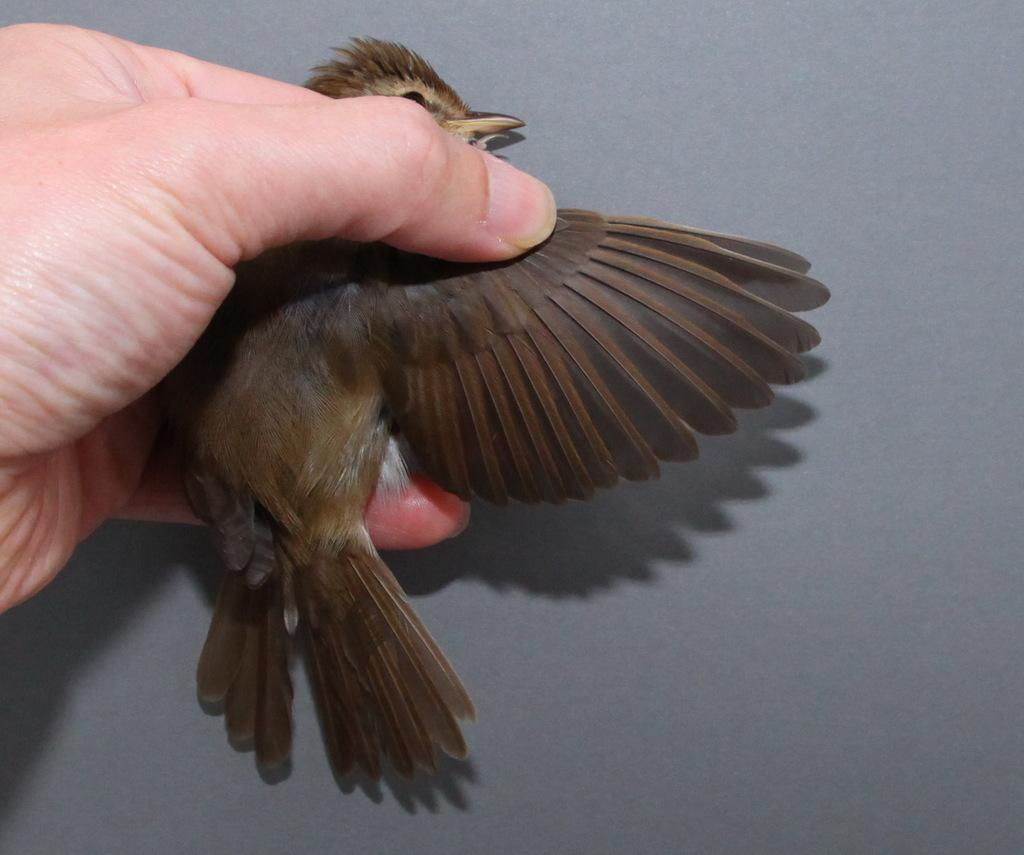What type of animal is in the image? There is a bird in the image. How is the bird being held in the image? The bird is in a person's hand. What color is the background of the image? The background of the image is gray. What type of gun is the bird holding in the image? There is no gun present in the image; the bird is being held by a person. Can you see any rats in the image? There are no rats present in the image; it features a bird in a person's hand with a gray background. 